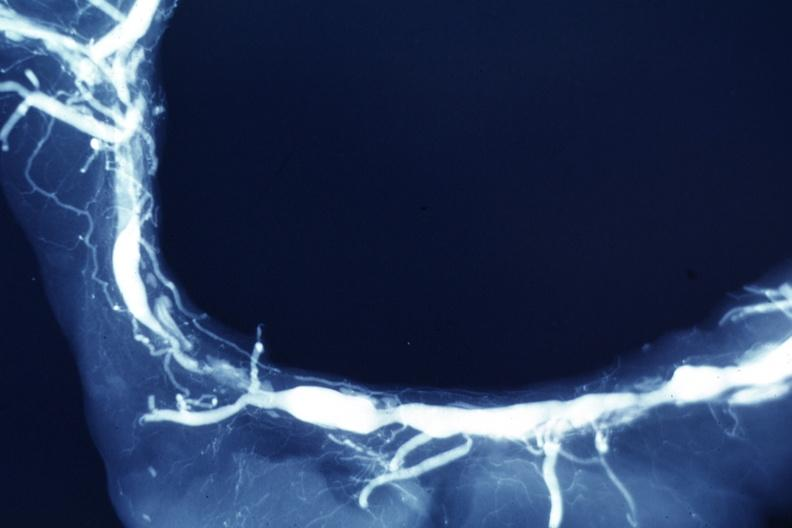s vasculature present?
Answer the question using a single word or phrase. Yes 